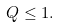<formula> <loc_0><loc_0><loc_500><loc_500>Q \leq 1 .</formula> 